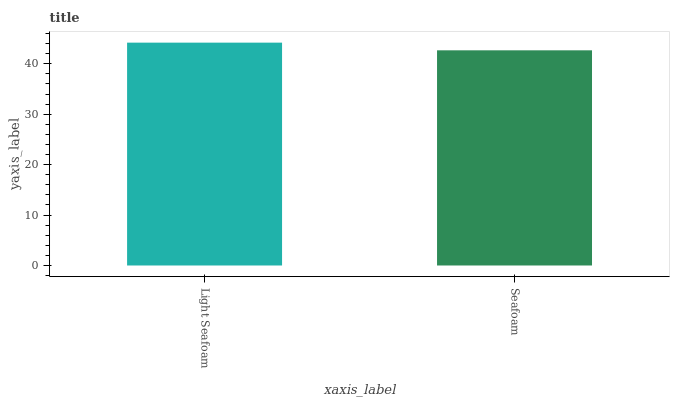Is Seafoam the minimum?
Answer yes or no. Yes. Is Light Seafoam the maximum?
Answer yes or no. Yes. Is Seafoam the maximum?
Answer yes or no. No. Is Light Seafoam greater than Seafoam?
Answer yes or no. Yes. Is Seafoam less than Light Seafoam?
Answer yes or no. Yes. Is Seafoam greater than Light Seafoam?
Answer yes or no. No. Is Light Seafoam less than Seafoam?
Answer yes or no. No. Is Light Seafoam the high median?
Answer yes or no. Yes. Is Seafoam the low median?
Answer yes or no. Yes. Is Seafoam the high median?
Answer yes or no. No. Is Light Seafoam the low median?
Answer yes or no. No. 